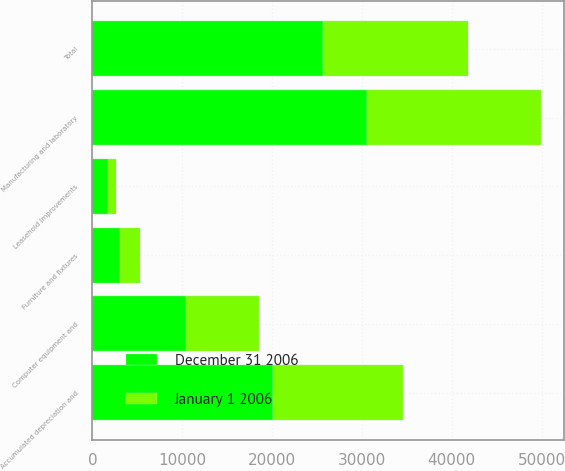Convert chart to OTSL. <chart><loc_0><loc_0><loc_500><loc_500><stacked_bar_chart><ecel><fcel>Leasehold improvements<fcel>Manufacturing and laboratory<fcel>Computer equipment and<fcel>Furniture and fixtures<fcel>Accumulated depreciation and<fcel>Total<nl><fcel>December 31 2006<fcel>1760<fcel>30523<fcel>10383<fcel>3114<fcel>20146<fcel>25634<nl><fcel>January 1 2006<fcel>819<fcel>19430<fcel>8121<fcel>2139<fcel>14378<fcel>16131<nl></chart> 